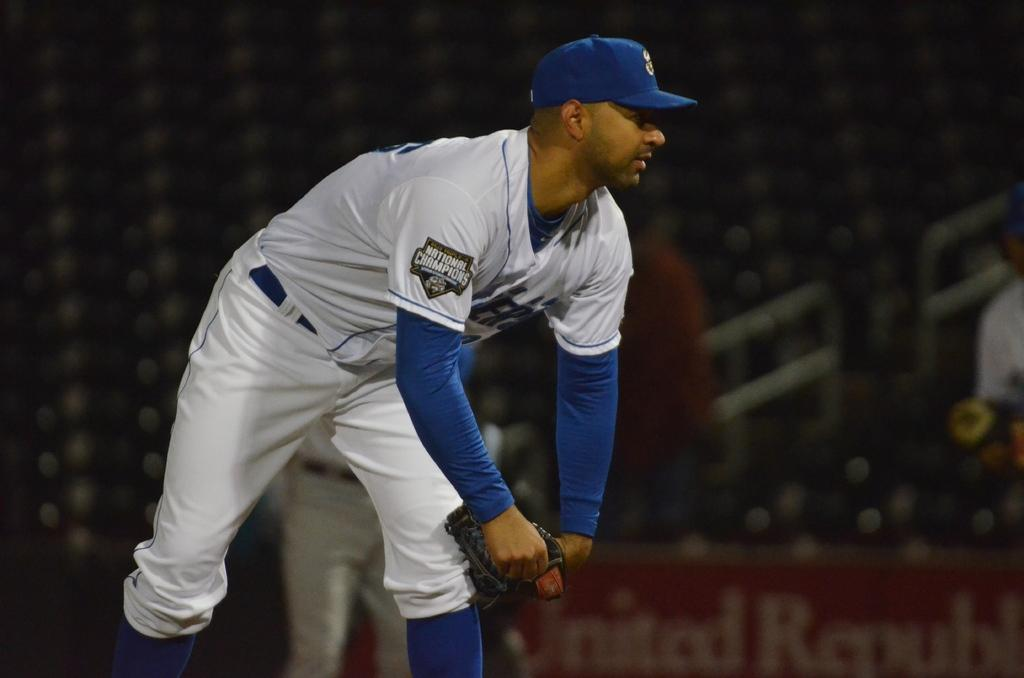<image>
Describe the image concisely. a National Champions baseball player bending downwards with a glove in his hands. 